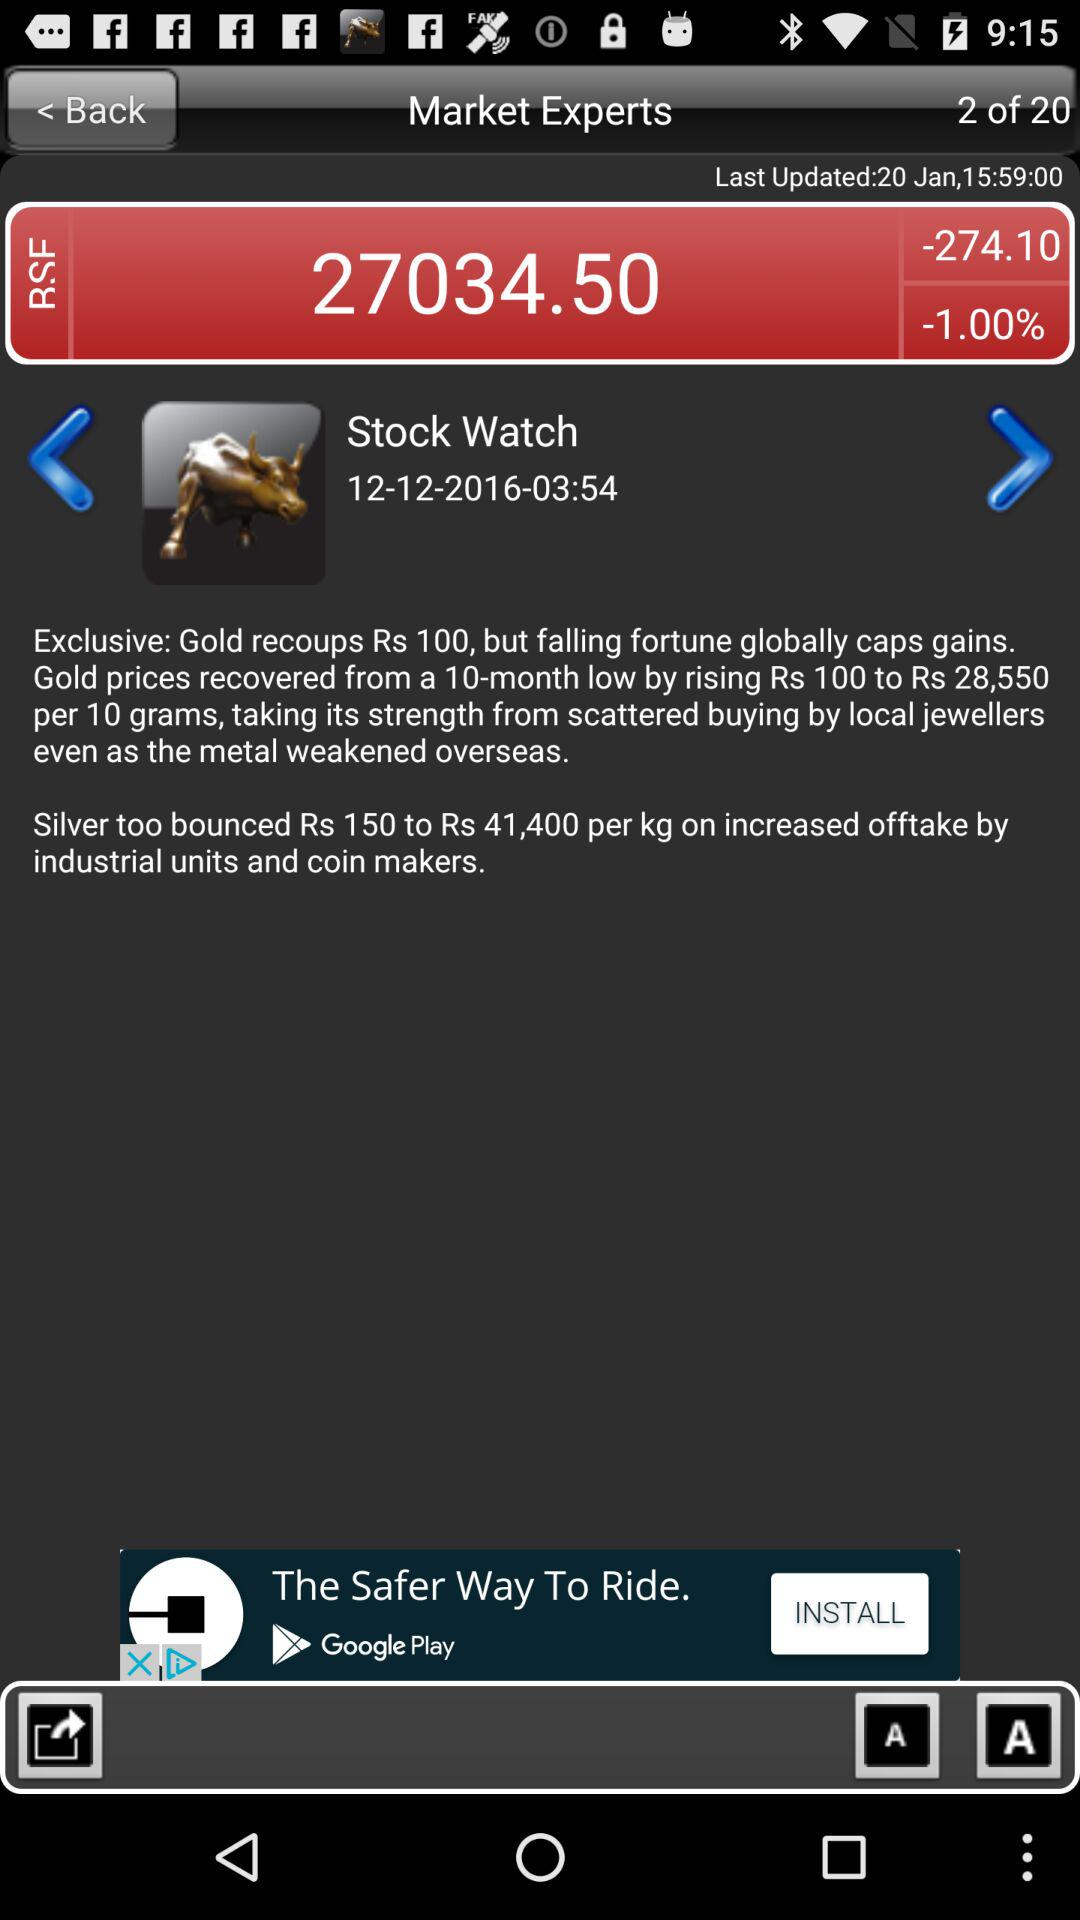When was it updated last? It was last updated on January 20 at 15:59. 